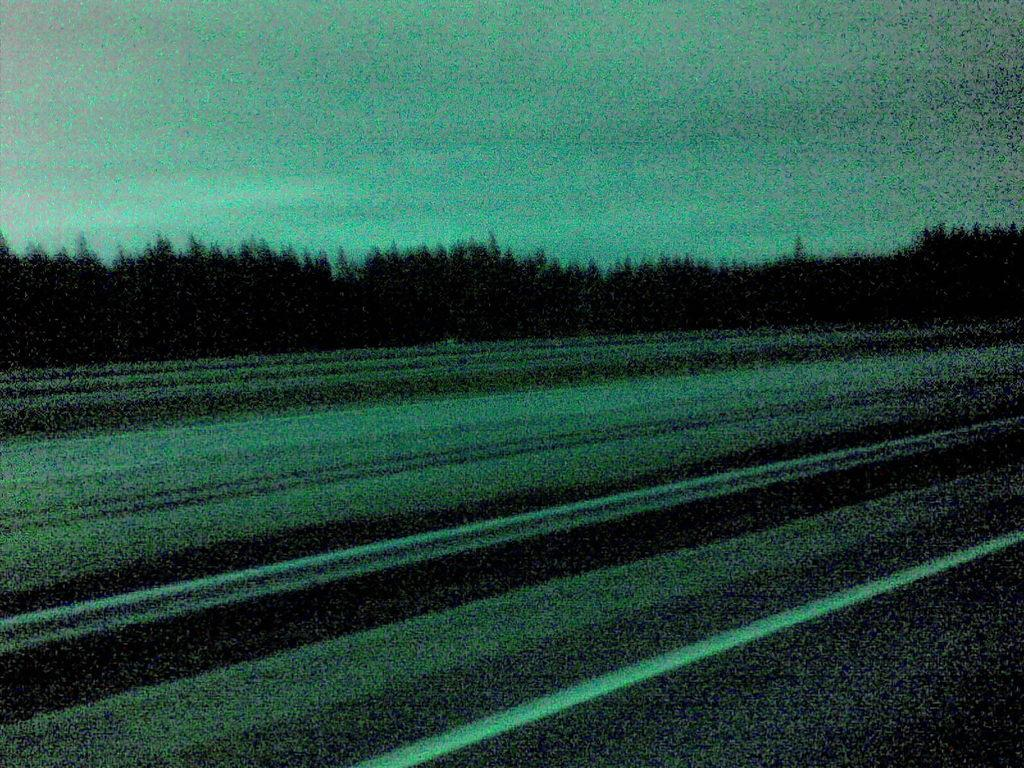What is the main feature of the image? There is a road in the image. What can be seen in the background of the image? There are trees in the background of the image. What part of the natural environment is visible in the image? The sky is visible in the image. What type of dress is the airport wearing in the image? There is no airport present in the image, and therefore no dress can be associated with it. 